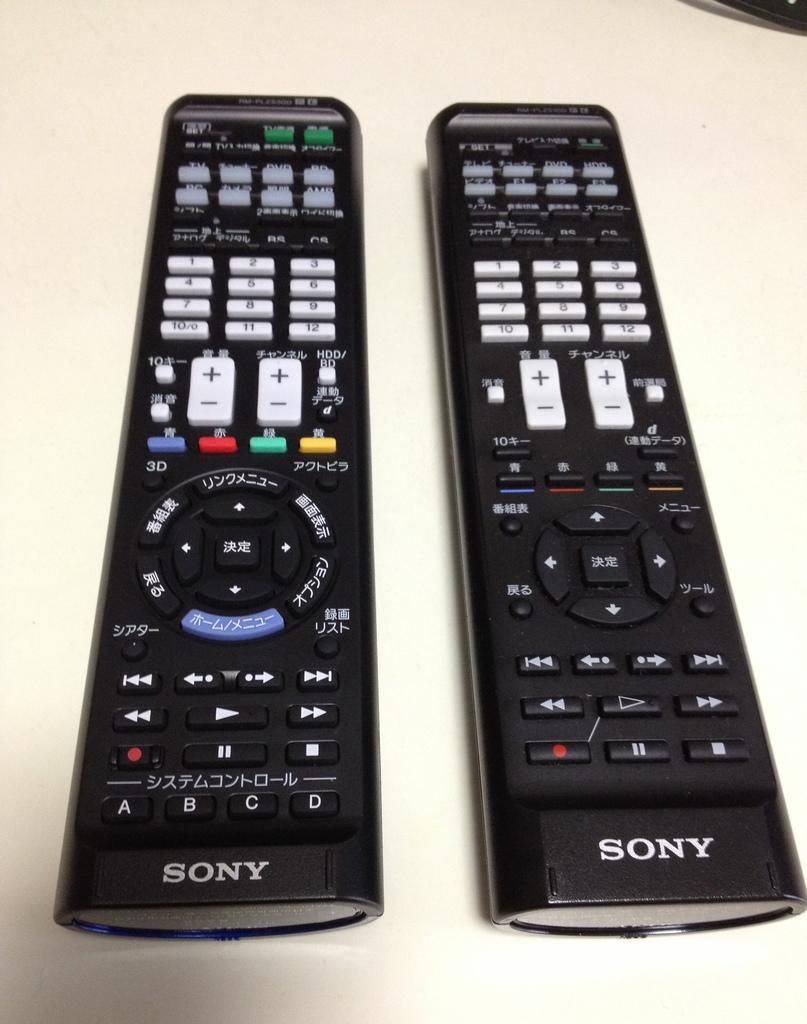What brand is the remote on the left?
Provide a succinct answer. Sony. What four letters beginning of the alphabet is on the left remote?
Offer a very short reply. Abcd. 